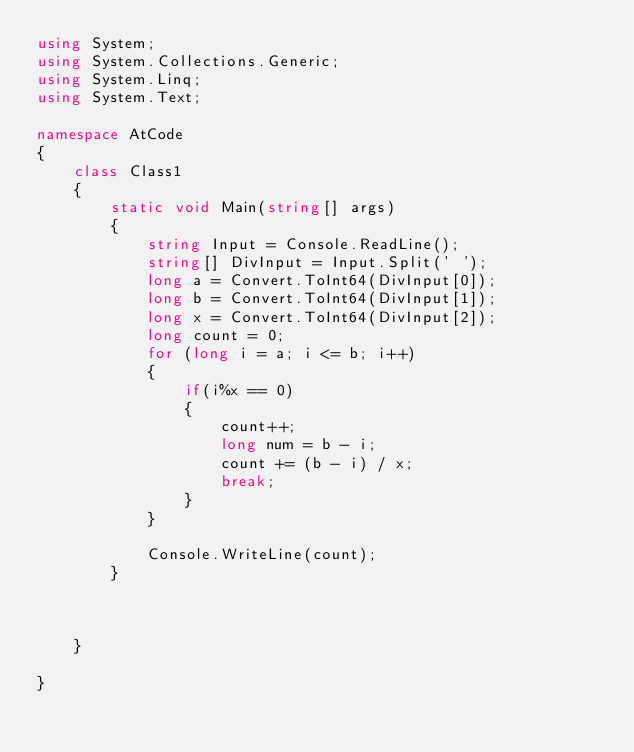<code> <loc_0><loc_0><loc_500><loc_500><_C#_>using System;
using System.Collections.Generic;
using System.Linq;
using System.Text;

namespace AtCode
{
    class Class1
    {
        static void Main(string[] args)
        {
            string Input = Console.ReadLine();
            string[] DivInput = Input.Split(' ');
            long a = Convert.ToInt64(DivInput[0]);
            long b = Convert.ToInt64(DivInput[1]);
            long x = Convert.ToInt64(DivInput[2]);
            long count = 0;
            for (long i = a; i <= b; i++)
            {
                if(i%x == 0)
                {
                    count++;
                    long num = b - i;
                    count += (b - i) / x;
                    break;
                }
            }
           
            Console.WriteLine(count);
        }
        

       
    }
    
}
</code> 